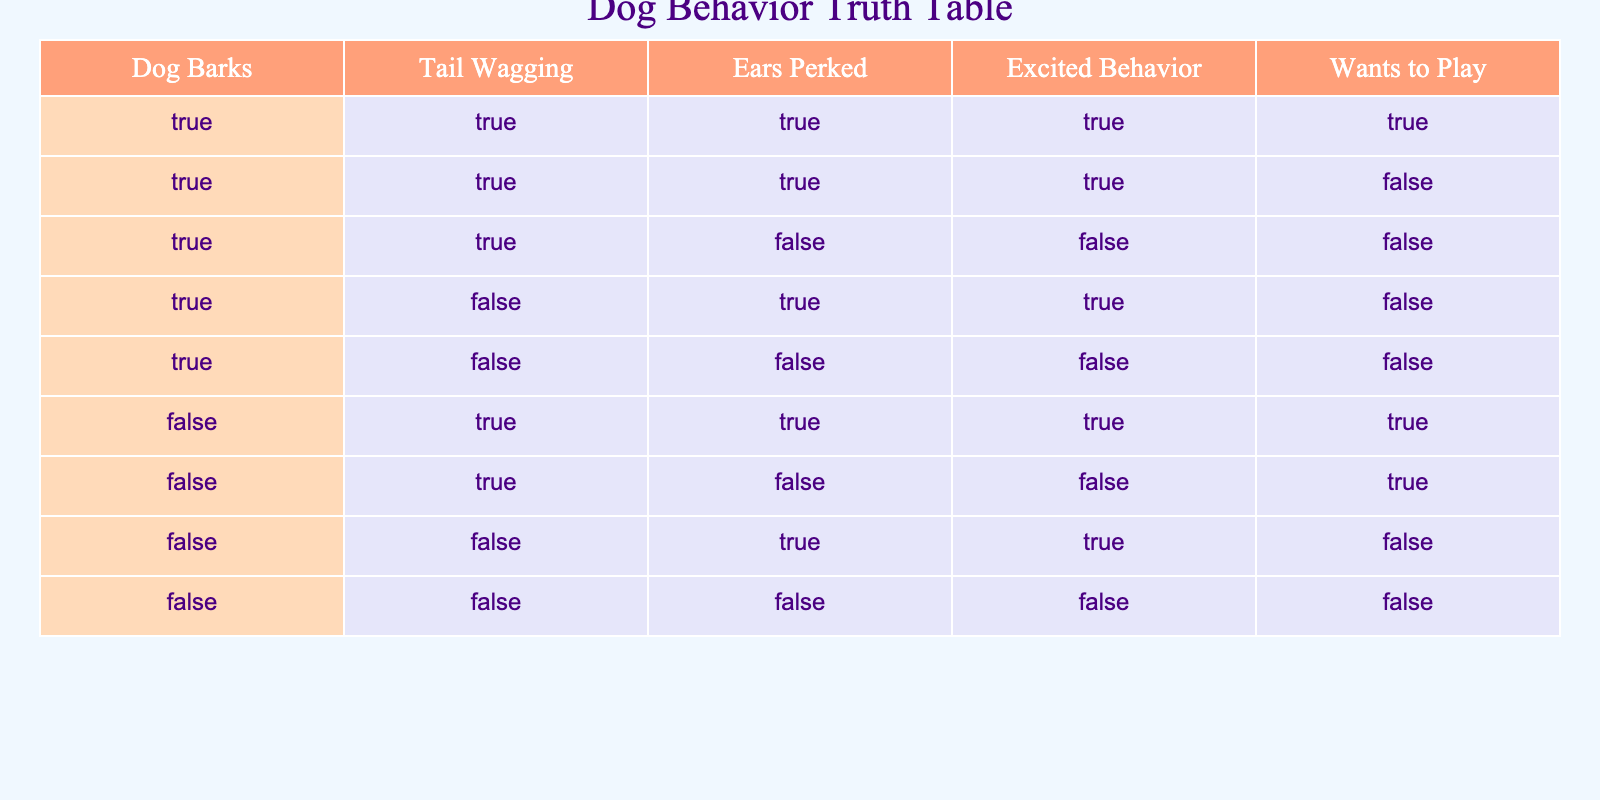What is the total number of situations where the dog barks and displays excited behavior? From the table, I will count the rows where both "Dog Barks" and "Excited Behavior" are true. There are 4 rows that satisfy these conditions: the 1st, 2nd, 4th, and 6th rows.
Answer: 4 In how many situations does the dog wag its tail but doesn't bark? I will look for rows where "Tail Wagging" is true and "Dog Barks" is false. There are 2 such situations: the 6th and 7th rows.
Answer: 2 Is there any instance when the dog is excited and wants to play? I will check if there are any rows where both "Excited Behavior" and "Wants to Play" are true. This occurs in the 1st row only.
Answer: Yes How many situations show that the dog has its ears perked while wagging its tail? I will check the table for cases where both "Ears Perked" and "Tail Wagging" are true. 3 rows meet this condition: the 1st, 2nd, and 6th rows.
Answer: 3 Are there any instances when the dog is not excited and does not want to play? To answer this, I check if there are rows where "Excited Behavior" is false and "Wants to Play" is also false. These circumstances are present in the 3rd, 5th, and 9th rows.
Answer: Yes What is the total number of true values for ear perks across all situations? I'll identify how many times "Ears Perked" is true, which is 5 occurrences: in the 1st, 2nd, 5th, 7th, and 8th rows.
Answer: 5 In how many cases does the dog bark without wagging its tail? I need to find rows where "Dog Barks" is true, while "Tail Wagging" is false. The 4th and 5th rows fit this description, making a total of 2 cases.
Answer: 2 When the dog is not barking, does it still show any excited behavior? I will determine if there are scenarios with "Dog Barks" false but "Excited Behavior" true. The 7th and 8th rows meet this condition, showing that it can be excited without barking.
Answer: Yes How many combinations of tail wagging and playing would you have if you added all mix variations? I will sum the valid combinations of "Tail Wagging" and "Wants to Play." There are 6 cases combining scenarios across the rows: 1st, 2nd, 6th, and 7th.
Answer: 6 